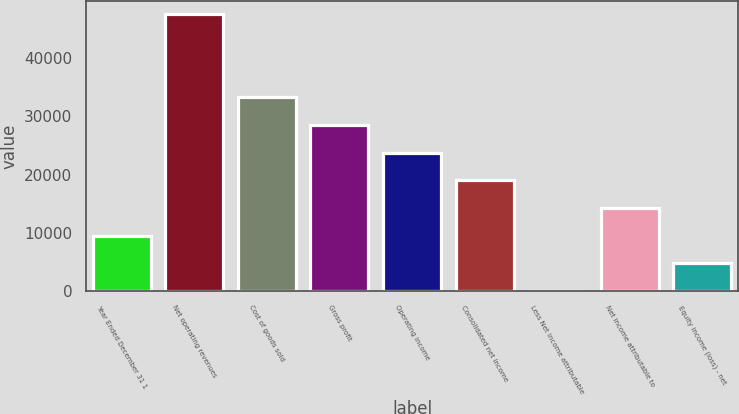Convert chart to OTSL. <chart><loc_0><loc_0><loc_500><loc_500><bar_chart><fcel>Year Ended December 31 1<fcel>Net operating revenues<fcel>Cost of goods sold<fcel>Gross profit<fcel>Operating income<fcel>Consolidated net income<fcel>Less Net income attributable<fcel>Net income attributable to<fcel>Equity income (loss) - net<nl><fcel>9551.6<fcel>47498<fcel>33268.1<fcel>28524.8<fcel>23781.5<fcel>19038.2<fcel>65<fcel>14294.9<fcel>4808.3<nl></chart> 